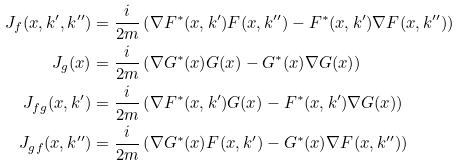Convert formula to latex. <formula><loc_0><loc_0><loc_500><loc_500>J _ { f } ( x , k ^ { \prime } , k ^ { \prime \prime } ) & = \frac { i } { 2 m } \left ( \nabla F ^ { * } ( x , k ^ { \prime } ) F ( x , k ^ { \prime \prime } ) - F ^ { * } ( x , k ^ { \prime } ) \nabla F ( x , k ^ { \prime \prime } ) \right ) \\ J _ { g } ( x ) & = \frac { i } { 2 m } \left ( \nabla G ^ { * } ( x ) G ( x ) - G ^ { * } ( x ) \nabla G ( x ) \right ) \\ J _ { f g } ( x , k ^ { \prime } ) & = \frac { i } { 2 m } \left ( \nabla F ^ { * } ( x , k ^ { \prime } ) G ( x ) - F ^ { * } ( x , k ^ { \prime } ) \nabla G ( x ) \right ) \\ J _ { g f } ( x , k ^ { \prime \prime } ) & = \frac { i } { 2 m } \left ( \nabla G ^ { * } ( x ) F ( x , k ^ { \prime } ) - G ^ { * } ( x ) \nabla F ( x , k ^ { \prime \prime } ) \right )</formula> 